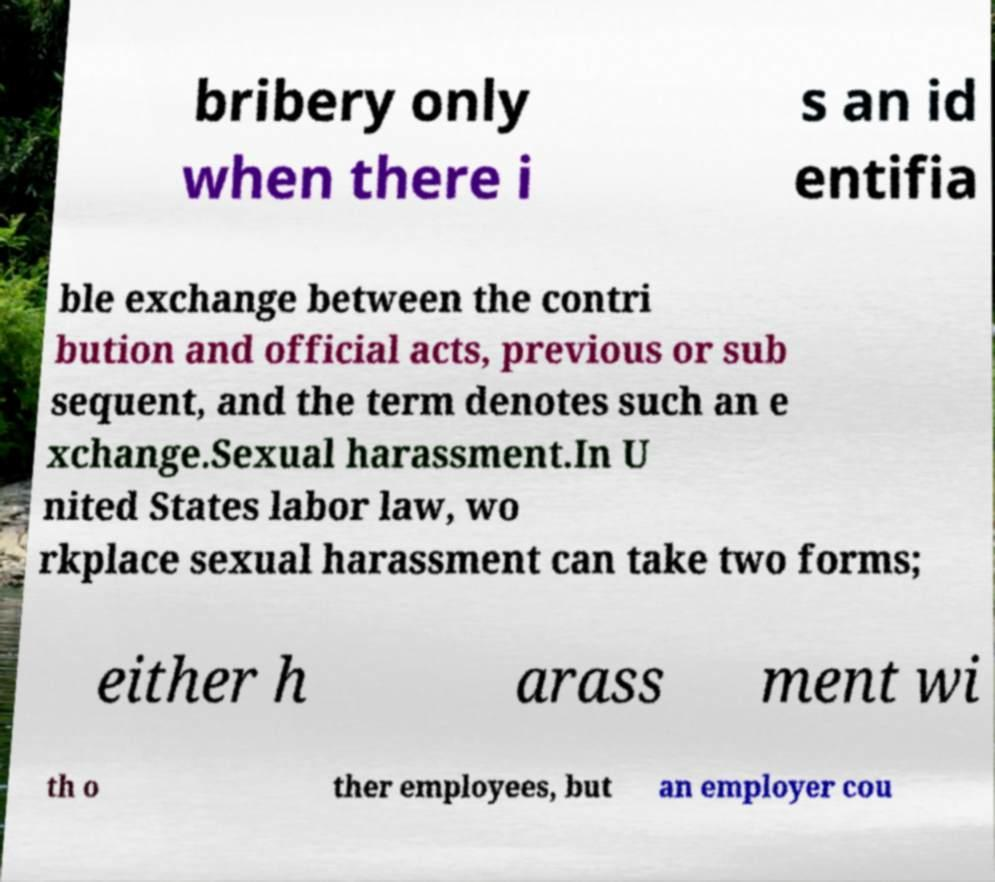Could you assist in decoding the text presented in this image and type it out clearly? bribery only when there i s an id entifia ble exchange between the contri bution and official acts, previous or sub sequent, and the term denotes such an e xchange.Sexual harassment.In U nited States labor law, wo rkplace sexual harassment can take two forms; either h arass ment wi th o ther employees, but an employer cou 